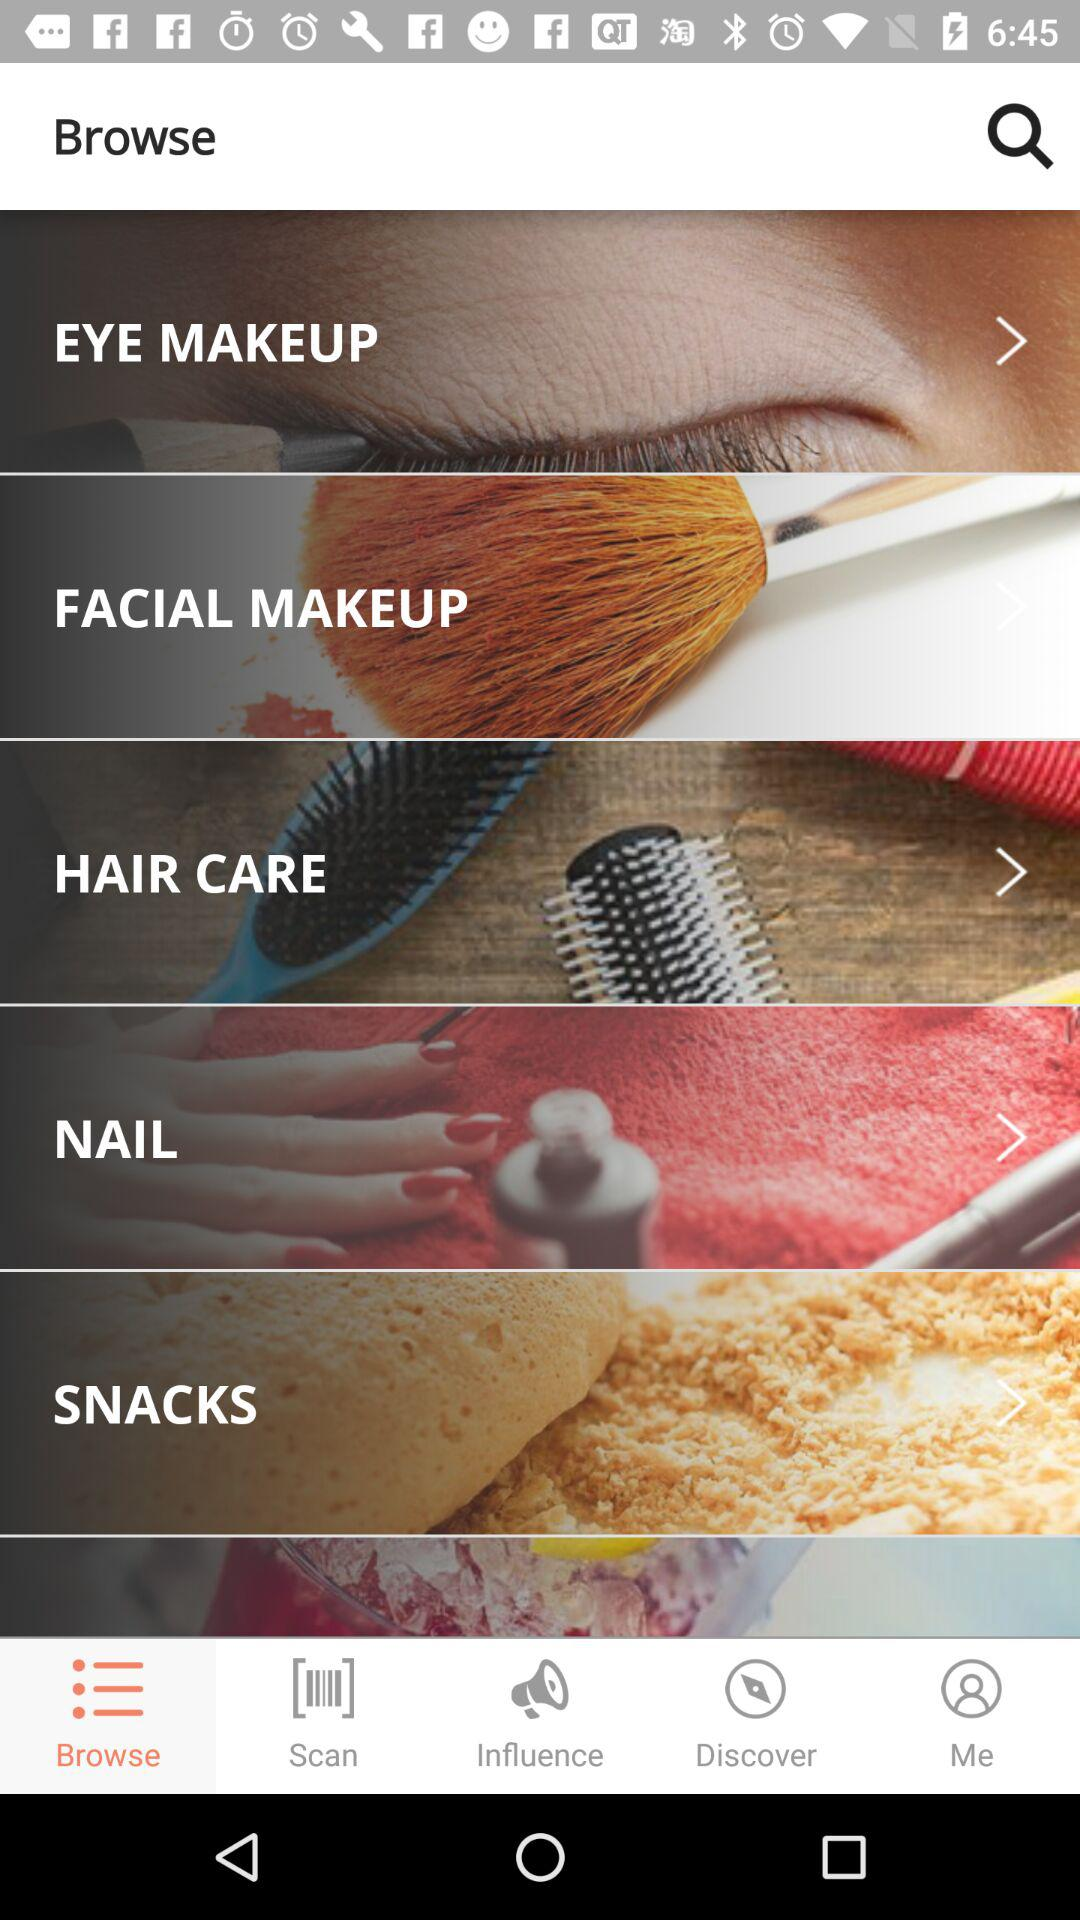Which tab is selected? The selected tab is "Browse". 